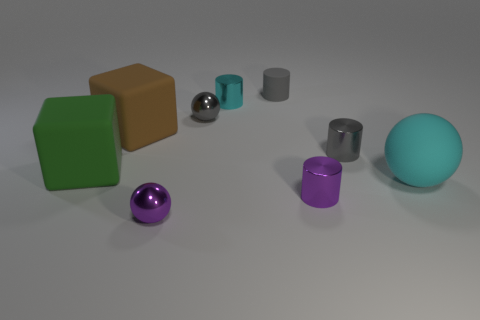Add 1 big brown balls. How many objects exist? 10 Subtract all purple cylinders. How many cylinders are left? 3 Subtract all purple metallic cylinders. How many cylinders are left? 3 Subtract all cubes. How many objects are left? 7 Subtract all yellow cylinders. Subtract all yellow spheres. How many cylinders are left? 4 Subtract all cyan cubes. Subtract all cyan rubber spheres. How many objects are left? 8 Add 7 big green matte blocks. How many big green matte blocks are left? 8 Add 8 big green metal blocks. How many big green metal blocks exist? 8 Subtract 0 green spheres. How many objects are left? 9 